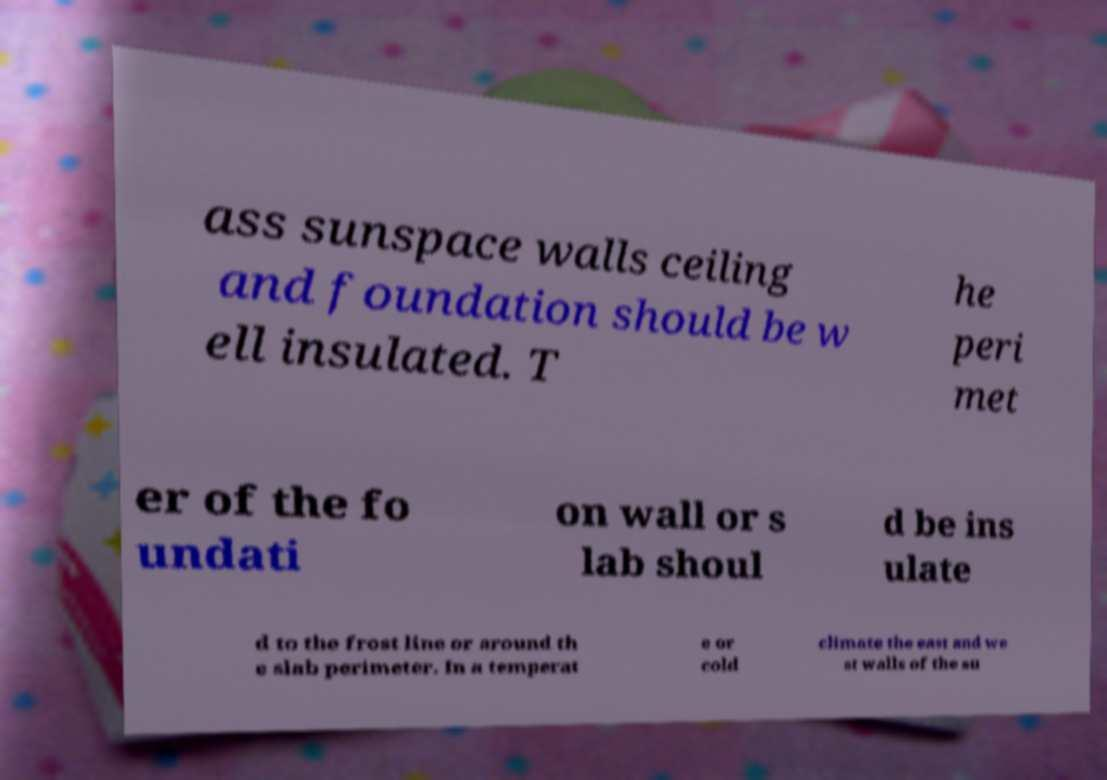For documentation purposes, I need the text within this image transcribed. Could you provide that? ass sunspace walls ceiling and foundation should be w ell insulated. T he peri met er of the fo undati on wall or s lab shoul d be ins ulate d to the frost line or around th e slab perimeter. In a temperat e or cold climate the east and we st walls of the su 